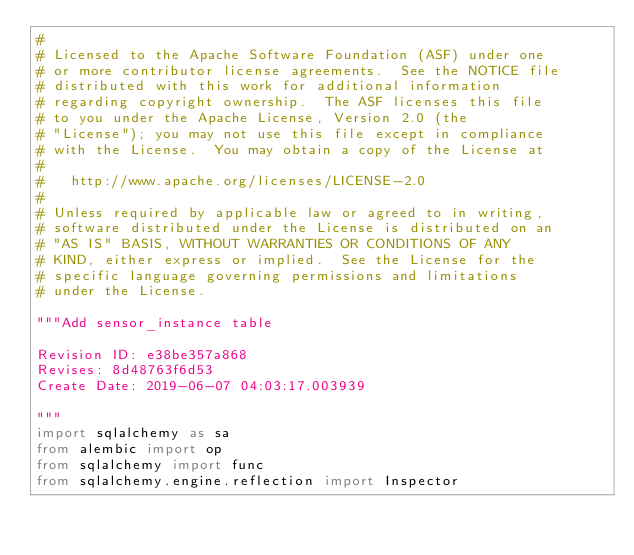<code> <loc_0><loc_0><loc_500><loc_500><_Python_>#
# Licensed to the Apache Software Foundation (ASF) under one
# or more contributor license agreements.  See the NOTICE file
# distributed with this work for additional information
# regarding copyright ownership.  The ASF licenses this file
# to you under the Apache License, Version 2.0 (the
# "License"); you may not use this file except in compliance
# with the License.  You may obtain a copy of the License at
#
#   http://www.apache.org/licenses/LICENSE-2.0
#
# Unless required by applicable law or agreed to in writing,
# software distributed under the License is distributed on an
# "AS IS" BASIS, WITHOUT WARRANTIES OR CONDITIONS OF ANY
# KIND, either express or implied.  See the License for the
# specific language governing permissions and limitations
# under the License.

"""Add sensor_instance table

Revision ID: e38be357a868
Revises: 8d48763f6d53
Create Date: 2019-06-07 04:03:17.003939

"""
import sqlalchemy as sa
from alembic import op
from sqlalchemy import func
from sqlalchemy.engine.reflection import Inspector
</code> 